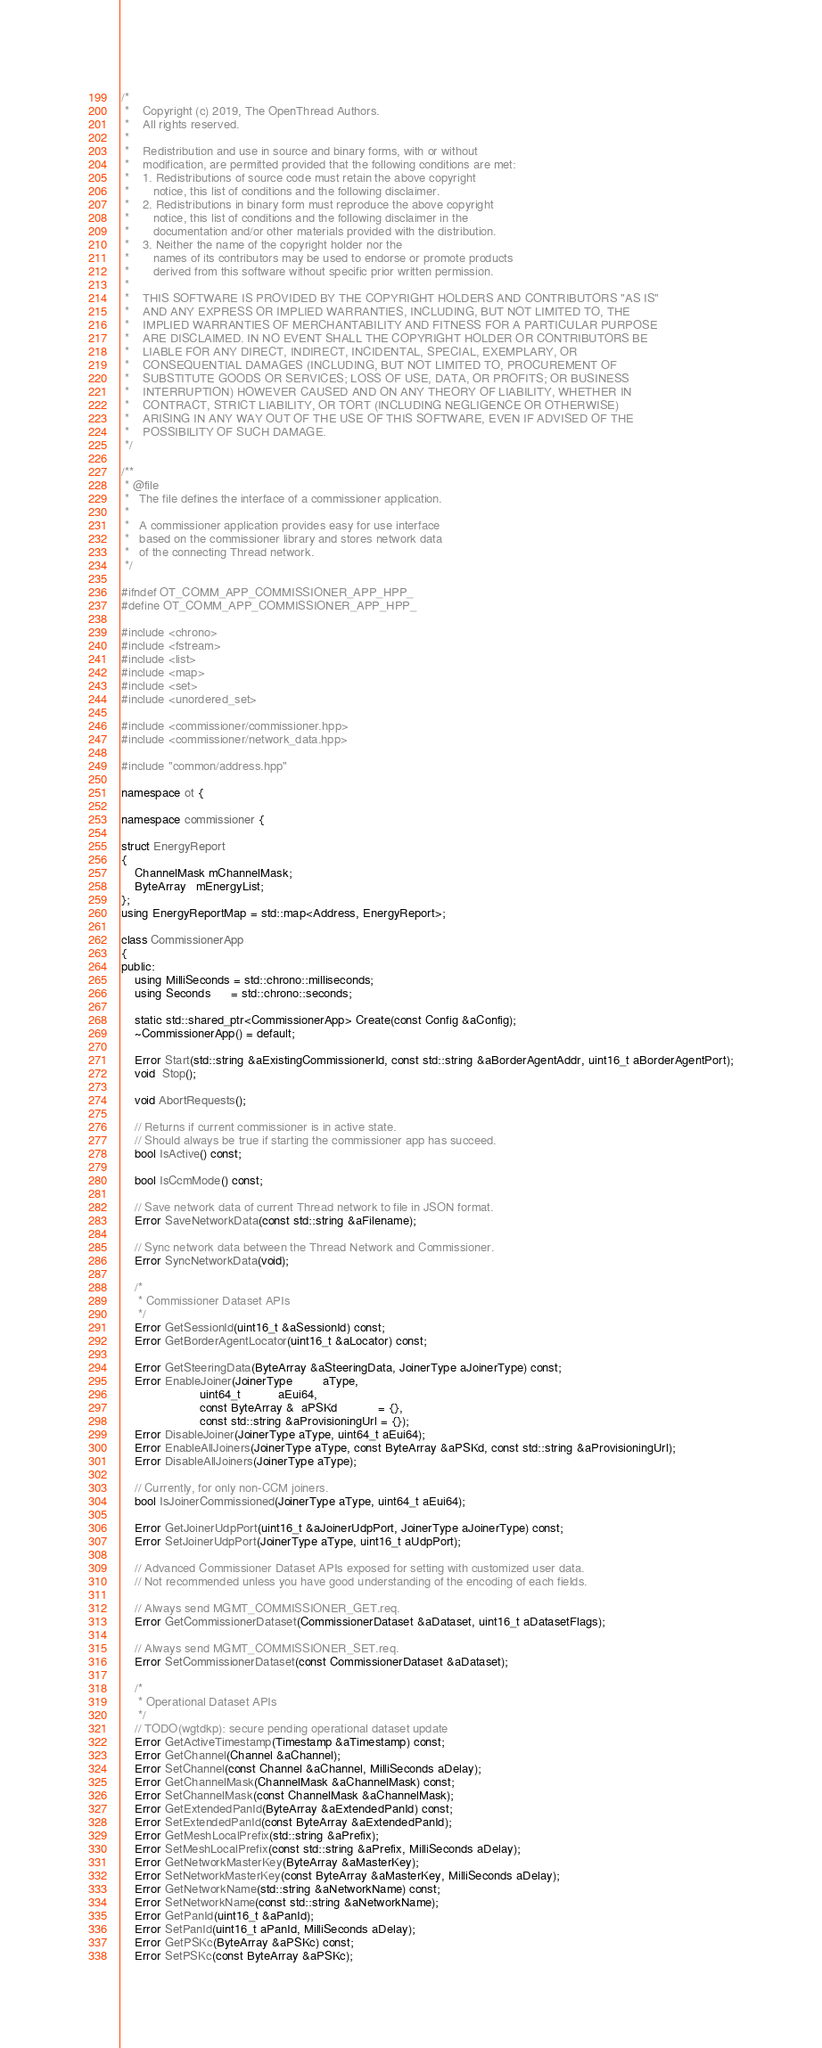Convert code to text. <code><loc_0><loc_0><loc_500><loc_500><_C++_>/*
 *    Copyright (c) 2019, The OpenThread Authors.
 *    All rights reserved.
 *
 *    Redistribution and use in source and binary forms, with or without
 *    modification, are permitted provided that the following conditions are met:
 *    1. Redistributions of source code must retain the above copyright
 *       notice, this list of conditions and the following disclaimer.
 *    2. Redistributions in binary form must reproduce the above copyright
 *       notice, this list of conditions and the following disclaimer in the
 *       documentation and/or other materials provided with the distribution.
 *    3. Neither the name of the copyright holder nor the
 *       names of its contributors may be used to endorse or promote products
 *       derived from this software without specific prior written permission.
 *
 *    THIS SOFTWARE IS PROVIDED BY THE COPYRIGHT HOLDERS AND CONTRIBUTORS "AS IS"
 *    AND ANY EXPRESS OR IMPLIED WARRANTIES, INCLUDING, BUT NOT LIMITED TO, THE
 *    IMPLIED WARRANTIES OF MERCHANTABILITY AND FITNESS FOR A PARTICULAR PURPOSE
 *    ARE DISCLAIMED. IN NO EVENT SHALL THE COPYRIGHT HOLDER OR CONTRIBUTORS BE
 *    LIABLE FOR ANY DIRECT, INDIRECT, INCIDENTAL, SPECIAL, EXEMPLARY, OR
 *    CONSEQUENTIAL DAMAGES (INCLUDING, BUT NOT LIMITED TO, PROCUREMENT OF
 *    SUBSTITUTE GOODS OR SERVICES; LOSS OF USE, DATA, OR PROFITS; OR BUSINESS
 *    INTERRUPTION) HOWEVER CAUSED AND ON ANY THEORY OF LIABILITY, WHETHER IN
 *    CONTRACT, STRICT LIABILITY, OR TORT (INCLUDING NEGLIGENCE OR OTHERWISE)
 *    ARISING IN ANY WAY OUT OF THE USE OF THIS SOFTWARE, EVEN IF ADVISED OF THE
 *    POSSIBILITY OF SUCH DAMAGE.
 */

/**
 * @file
 *   The file defines the interface of a commissioner application.
 *
 *   A commissioner application provides easy for use interface
 *   based on the commissioner library and stores network data
 *   of the connecting Thread network.
 */

#ifndef OT_COMM_APP_COMMISSIONER_APP_HPP_
#define OT_COMM_APP_COMMISSIONER_APP_HPP_

#include <chrono>
#include <fstream>
#include <list>
#include <map>
#include <set>
#include <unordered_set>

#include <commissioner/commissioner.hpp>
#include <commissioner/network_data.hpp>

#include "common/address.hpp"

namespace ot {

namespace commissioner {

struct EnergyReport
{
    ChannelMask mChannelMask;
    ByteArray   mEnergyList;
};
using EnergyReportMap = std::map<Address, EnergyReport>;

class CommissionerApp
{
public:
    using MilliSeconds = std::chrono::milliseconds;
    using Seconds      = std::chrono::seconds;

    static std::shared_ptr<CommissionerApp> Create(const Config &aConfig);
    ~CommissionerApp() = default;

    Error Start(std::string &aExistingCommissionerId, const std::string &aBorderAgentAddr, uint16_t aBorderAgentPort);
    void  Stop();

    void AbortRequests();

    // Returns if current commissioner is in active state.
    // Should always be true if starting the commissioner app has succeed.
    bool IsActive() const;

    bool IsCcmMode() const;

    // Save network data of current Thread network to file in JSON format.
    Error SaveNetworkData(const std::string &aFilename);

    // Sync network data between the Thread Network and Commissioner.
    Error SyncNetworkData(void);

    /*
     * Commissioner Dataset APIs
     */
    Error GetSessionId(uint16_t &aSessionId) const;
    Error GetBorderAgentLocator(uint16_t &aLocator) const;

    Error GetSteeringData(ByteArray &aSteeringData, JoinerType aJoinerType) const;
    Error EnableJoiner(JoinerType         aType,
                       uint64_t           aEui64,
                       const ByteArray &  aPSKd            = {},
                       const std::string &aProvisioningUrl = {});
    Error DisableJoiner(JoinerType aType, uint64_t aEui64);
    Error EnableAllJoiners(JoinerType aType, const ByteArray &aPSKd, const std::string &aProvisioningUrl);
    Error DisableAllJoiners(JoinerType aType);

    // Currently, for only non-CCM joiners.
    bool IsJoinerCommissioned(JoinerType aType, uint64_t aEui64);

    Error GetJoinerUdpPort(uint16_t &aJoinerUdpPort, JoinerType aJoinerType) const;
    Error SetJoinerUdpPort(JoinerType aType, uint16_t aUdpPort);

    // Advanced Commissioner Dataset APIs exposed for setting with customized user data.
    // Not recommended unless you have good understanding of the encoding of each fields.

    // Always send MGMT_COMMISSIONER_GET.req.
    Error GetCommissionerDataset(CommissionerDataset &aDataset, uint16_t aDatasetFlags);

    // Always send MGMT_COMMISSIONER_SET.req.
    Error SetCommissionerDataset(const CommissionerDataset &aDataset);

    /*
     * Operational Dataset APIs
     */
    // TODO(wgtdkp): secure pending operational dataset update
    Error GetActiveTimestamp(Timestamp &aTimestamp) const;
    Error GetChannel(Channel &aChannel);
    Error SetChannel(const Channel &aChannel, MilliSeconds aDelay);
    Error GetChannelMask(ChannelMask &aChannelMask) const;
    Error SetChannelMask(const ChannelMask &aChannelMask);
    Error GetExtendedPanId(ByteArray &aExtendedPanId) const;
    Error SetExtendedPanId(const ByteArray &aExtendedPanId);
    Error GetMeshLocalPrefix(std::string &aPrefix);
    Error SetMeshLocalPrefix(const std::string &aPrefix, MilliSeconds aDelay);
    Error GetNetworkMasterKey(ByteArray &aMasterKey);
    Error SetNetworkMasterKey(const ByteArray &aMasterKey, MilliSeconds aDelay);
    Error GetNetworkName(std::string &aNetworkName) const;
    Error SetNetworkName(const std::string &aNetworkName);
    Error GetPanId(uint16_t &aPanId);
    Error SetPanId(uint16_t aPanId, MilliSeconds aDelay);
    Error GetPSKc(ByteArray &aPSKc) const;
    Error SetPSKc(const ByteArray &aPSKc);
</code> 